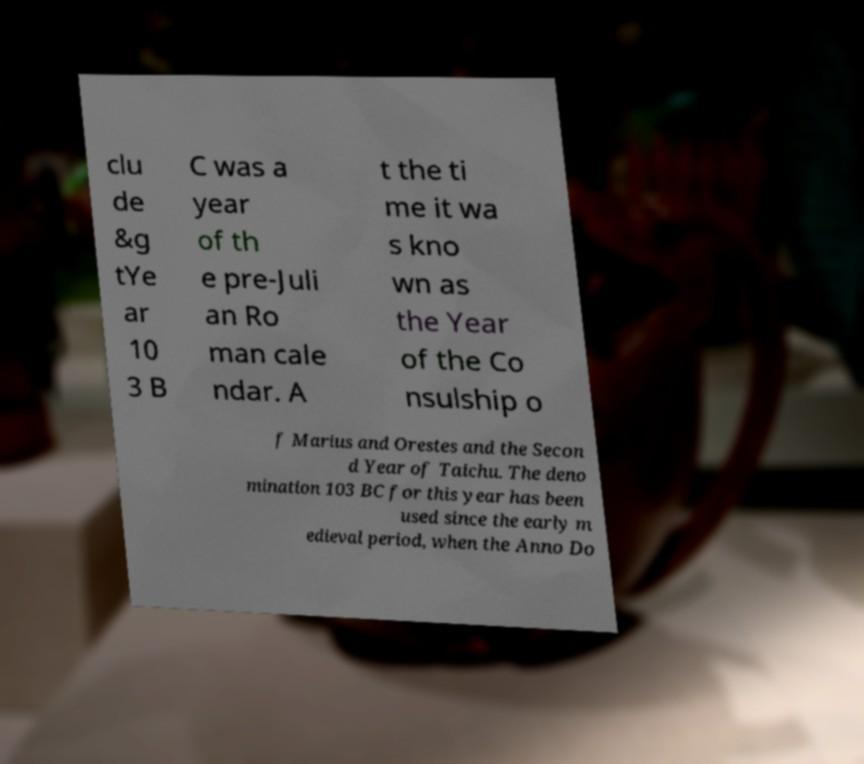Could you assist in decoding the text presented in this image and type it out clearly? clu de &g tYe ar 10 3 B C was a year of th e pre-Juli an Ro man cale ndar. A t the ti me it wa s kno wn as the Year of the Co nsulship o f Marius and Orestes and the Secon d Year of Taichu. The deno mination 103 BC for this year has been used since the early m edieval period, when the Anno Do 